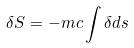Convert formula to latex. <formula><loc_0><loc_0><loc_500><loc_500>\delta S = - m c \int \delta d s</formula> 